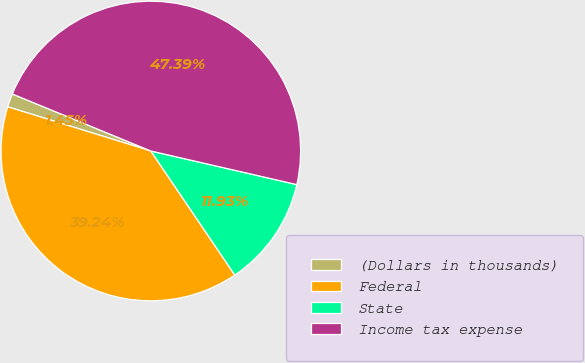Convert chart to OTSL. <chart><loc_0><loc_0><loc_500><loc_500><pie_chart><fcel>(Dollars in thousands)<fcel>Federal<fcel>State<fcel>Income tax expense<nl><fcel>1.45%<fcel>39.24%<fcel>11.93%<fcel>47.39%<nl></chart> 